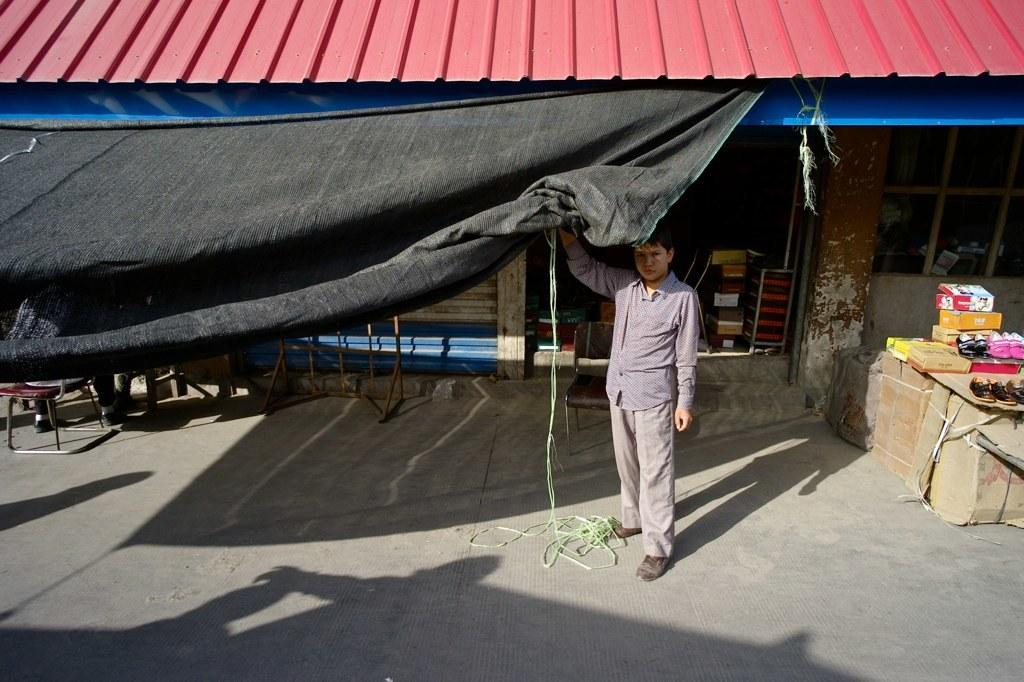Who is present in the image? There is a man in the image. What is the tent cloth used for? The tent cloth is not explicitly used for anything in the image, but it is present. What can be seen in the background of the image? There is a shop in the background of the image. What is on the right side of the image? There are boxes on the right side of the image, and footwear is on top of the boxes. What type of match can be seen being played in the image? There is no match being played in the image; it does not depict any sporting activity. 